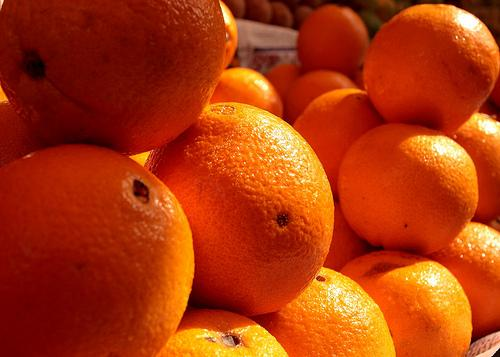What fruit is in the picture? Please explain your reasoning. oranges. This fruit is the same color. 